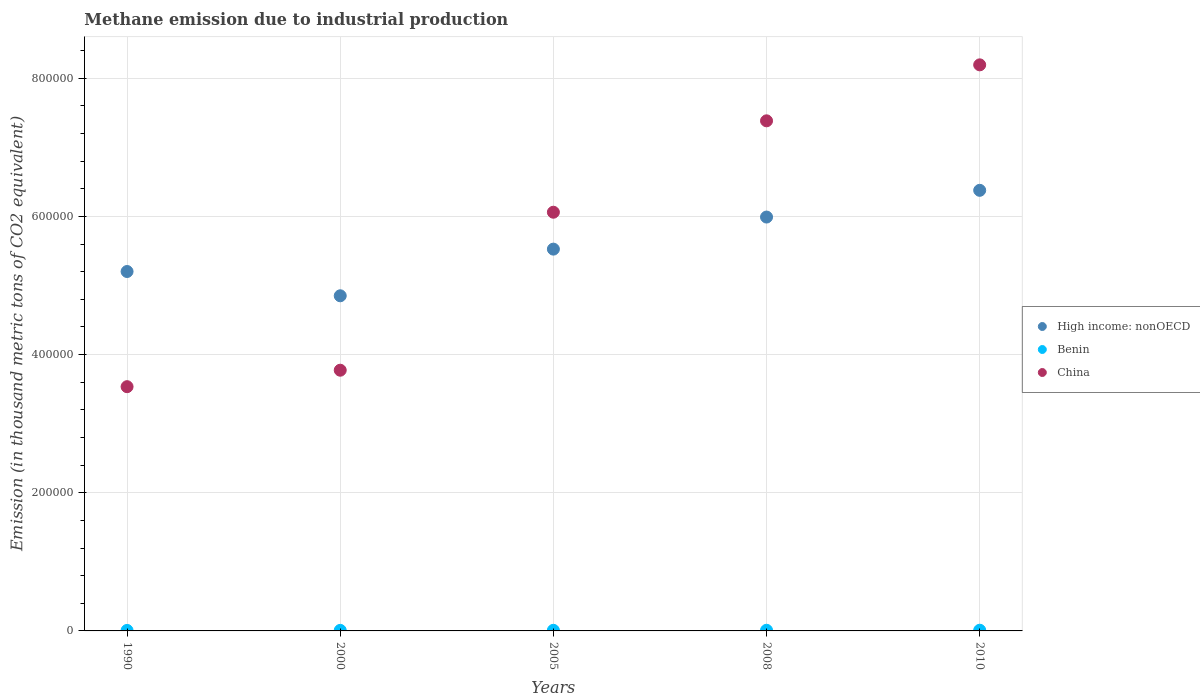What is the amount of methane emitted in High income: nonOECD in 2005?
Your answer should be compact. 5.53e+05. Across all years, what is the maximum amount of methane emitted in Benin?
Offer a terse response. 1014.3. Across all years, what is the minimum amount of methane emitted in Benin?
Keep it short and to the point. 711.4. In which year was the amount of methane emitted in High income: nonOECD minimum?
Ensure brevity in your answer.  2000. What is the total amount of methane emitted in China in the graph?
Offer a very short reply. 2.89e+06. What is the difference between the amount of methane emitted in High income: nonOECD in 1990 and that in 2010?
Keep it short and to the point. -1.18e+05. What is the difference between the amount of methane emitted in Benin in 2005 and the amount of methane emitted in High income: nonOECD in 2010?
Your answer should be compact. -6.37e+05. What is the average amount of methane emitted in China per year?
Provide a succinct answer. 5.79e+05. In the year 2000, what is the difference between the amount of methane emitted in High income: nonOECD and amount of methane emitted in Benin?
Offer a terse response. 4.84e+05. In how many years, is the amount of methane emitted in China greater than 40000 thousand metric tons?
Provide a short and direct response. 5. What is the ratio of the amount of methane emitted in Benin in 1990 to that in 2008?
Give a very brief answer. 0.75. What is the difference between the highest and the second highest amount of methane emitted in China?
Provide a succinct answer. 8.10e+04. What is the difference between the highest and the lowest amount of methane emitted in China?
Ensure brevity in your answer.  4.66e+05. Does the amount of methane emitted in Benin monotonically increase over the years?
Provide a succinct answer. Yes. Is the amount of methane emitted in China strictly less than the amount of methane emitted in Benin over the years?
Your answer should be compact. No. What is the difference between two consecutive major ticks on the Y-axis?
Provide a short and direct response. 2.00e+05. How many legend labels are there?
Make the answer very short. 3. What is the title of the graph?
Make the answer very short. Methane emission due to industrial production. Does "Small states" appear as one of the legend labels in the graph?
Make the answer very short. No. What is the label or title of the Y-axis?
Your response must be concise. Emission (in thousand metric tons of CO2 equivalent). What is the Emission (in thousand metric tons of CO2 equivalent) of High income: nonOECD in 1990?
Ensure brevity in your answer.  5.20e+05. What is the Emission (in thousand metric tons of CO2 equivalent) of Benin in 1990?
Make the answer very short. 711.4. What is the Emission (in thousand metric tons of CO2 equivalent) in China in 1990?
Ensure brevity in your answer.  3.54e+05. What is the Emission (in thousand metric tons of CO2 equivalent) in High income: nonOECD in 2000?
Provide a short and direct response. 4.85e+05. What is the Emission (in thousand metric tons of CO2 equivalent) in Benin in 2000?
Offer a terse response. 817.2. What is the Emission (in thousand metric tons of CO2 equivalent) of China in 2000?
Provide a short and direct response. 3.77e+05. What is the Emission (in thousand metric tons of CO2 equivalent) in High income: nonOECD in 2005?
Give a very brief answer. 5.53e+05. What is the Emission (in thousand metric tons of CO2 equivalent) of Benin in 2005?
Your answer should be very brief. 898.1. What is the Emission (in thousand metric tons of CO2 equivalent) of China in 2005?
Your response must be concise. 6.06e+05. What is the Emission (in thousand metric tons of CO2 equivalent) of High income: nonOECD in 2008?
Offer a very short reply. 5.99e+05. What is the Emission (in thousand metric tons of CO2 equivalent) in Benin in 2008?
Offer a very short reply. 950.4. What is the Emission (in thousand metric tons of CO2 equivalent) of China in 2008?
Give a very brief answer. 7.38e+05. What is the Emission (in thousand metric tons of CO2 equivalent) in High income: nonOECD in 2010?
Offer a very short reply. 6.38e+05. What is the Emission (in thousand metric tons of CO2 equivalent) of Benin in 2010?
Offer a terse response. 1014.3. What is the Emission (in thousand metric tons of CO2 equivalent) in China in 2010?
Your answer should be very brief. 8.19e+05. Across all years, what is the maximum Emission (in thousand metric tons of CO2 equivalent) of High income: nonOECD?
Make the answer very short. 6.38e+05. Across all years, what is the maximum Emission (in thousand metric tons of CO2 equivalent) in Benin?
Offer a terse response. 1014.3. Across all years, what is the maximum Emission (in thousand metric tons of CO2 equivalent) in China?
Offer a very short reply. 8.19e+05. Across all years, what is the minimum Emission (in thousand metric tons of CO2 equivalent) of High income: nonOECD?
Provide a short and direct response. 4.85e+05. Across all years, what is the minimum Emission (in thousand metric tons of CO2 equivalent) of Benin?
Keep it short and to the point. 711.4. Across all years, what is the minimum Emission (in thousand metric tons of CO2 equivalent) of China?
Your answer should be compact. 3.54e+05. What is the total Emission (in thousand metric tons of CO2 equivalent) in High income: nonOECD in the graph?
Ensure brevity in your answer.  2.79e+06. What is the total Emission (in thousand metric tons of CO2 equivalent) in Benin in the graph?
Ensure brevity in your answer.  4391.4. What is the total Emission (in thousand metric tons of CO2 equivalent) in China in the graph?
Your response must be concise. 2.89e+06. What is the difference between the Emission (in thousand metric tons of CO2 equivalent) of High income: nonOECD in 1990 and that in 2000?
Your answer should be compact. 3.51e+04. What is the difference between the Emission (in thousand metric tons of CO2 equivalent) of Benin in 1990 and that in 2000?
Your response must be concise. -105.8. What is the difference between the Emission (in thousand metric tons of CO2 equivalent) in China in 1990 and that in 2000?
Your response must be concise. -2.38e+04. What is the difference between the Emission (in thousand metric tons of CO2 equivalent) of High income: nonOECD in 1990 and that in 2005?
Your answer should be very brief. -3.24e+04. What is the difference between the Emission (in thousand metric tons of CO2 equivalent) in Benin in 1990 and that in 2005?
Offer a very short reply. -186.7. What is the difference between the Emission (in thousand metric tons of CO2 equivalent) of China in 1990 and that in 2005?
Ensure brevity in your answer.  -2.53e+05. What is the difference between the Emission (in thousand metric tons of CO2 equivalent) of High income: nonOECD in 1990 and that in 2008?
Ensure brevity in your answer.  -7.88e+04. What is the difference between the Emission (in thousand metric tons of CO2 equivalent) of Benin in 1990 and that in 2008?
Offer a terse response. -239. What is the difference between the Emission (in thousand metric tons of CO2 equivalent) of China in 1990 and that in 2008?
Provide a short and direct response. -3.85e+05. What is the difference between the Emission (in thousand metric tons of CO2 equivalent) in High income: nonOECD in 1990 and that in 2010?
Ensure brevity in your answer.  -1.18e+05. What is the difference between the Emission (in thousand metric tons of CO2 equivalent) of Benin in 1990 and that in 2010?
Ensure brevity in your answer.  -302.9. What is the difference between the Emission (in thousand metric tons of CO2 equivalent) in China in 1990 and that in 2010?
Offer a terse response. -4.66e+05. What is the difference between the Emission (in thousand metric tons of CO2 equivalent) in High income: nonOECD in 2000 and that in 2005?
Make the answer very short. -6.75e+04. What is the difference between the Emission (in thousand metric tons of CO2 equivalent) in Benin in 2000 and that in 2005?
Your response must be concise. -80.9. What is the difference between the Emission (in thousand metric tons of CO2 equivalent) in China in 2000 and that in 2005?
Provide a succinct answer. -2.29e+05. What is the difference between the Emission (in thousand metric tons of CO2 equivalent) in High income: nonOECD in 2000 and that in 2008?
Your answer should be compact. -1.14e+05. What is the difference between the Emission (in thousand metric tons of CO2 equivalent) of Benin in 2000 and that in 2008?
Provide a short and direct response. -133.2. What is the difference between the Emission (in thousand metric tons of CO2 equivalent) in China in 2000 and that in 2008?
Ensure brevity in your answer.  -3.61e+05. What is the difference between the Emission (in thousand metric tons of CO2 equivalent) in High income: nonOECD in 2000 and that in 2010?
Provide a succinct answer. -1.53e+05. What is the difference between the Emission (in thousand metric tons of CO2 equivalent) in Benin in 2000 and that in 2010?
Your answer should be very brief. -197.1. What is the difference between the Emission (in thousand metric tons of CO2 equivalent) of China in 2000 and that in 2010?
Make the answer very short. -4.42e+05. What is the difference between the Emission (in thousand metric tons of CO2 equivalent) of High income: nonOECD in 2005 and that in 2008?
Give a very brief answer. -4.64e+04. What is the difference between the Emission (in thousand metric tons of CO2 equivalent) in Benin in 2005 and that in 2008?
Give a very brief answer. -52.3. What is the difference between the Emission (in thousand metric tons of CO2 equivalent) of China in 2005 and that in 2008?
Make the answer very short. -1.32e+05. What is the difference between the Emission (in thousand metric tons of CO2 equivalent) in High income: nonOECD in 2005 and that in 2010?
Provide a short and direct response. -8.51e+04. What is the difference between the Emission (in thousand metric tons of CO2 equivalent) in Benin in 2005 and that in 2010?
Your response must be concise. -116.2. What is the difference between the Emission (in thousand metric tons of CO2 equivalent) of China in 2005 and that in 2010?
Provide a short and direct response. -2.13e+05. What is the difference between the Emission (in thousand metric tons of CO2 equivalent) in High income: nonOECD in 2008 and that in 2010?
Provide a short and direct response. -3.87e+04. What is the difference between the Emission (in thousand metric tons of CO2 equivalent) in Benin in 2008 and that in 2010?
Make the answer very short. -63.9. What is the difference between the Emission (in thousand metric tons of CO2 equivalent) in China in 2008 and that in 2010?
Your response must be concise. -8.10e+04. What is the difference between the Emission (in thousand metric tons of CO2 equivalent) in High income: nonOECD in 1990 and the Emission (in thousand metric tons of CO2 equivalent) in Benin in 2000?
Offer a very short reply. 5.19e+05. What is the difference between the Emission (in thousand metric tons of CO2 equivalent) in High income: nonOECD in 1990 and the Emission (in thousand metric tons of CO2 equivalent) in China in 2000?
Offer a terse response. 1.43e+05. What is the difference between the Emission (in thousand metric tons of CO2 equivalent) of Benin in 1990 and the Emission (in thousand metric tons of CO2 equivalent) of China in 2000?
Make the answer very short. -3.77e+05. What is the difference between the Emission (in thousand metric tons of CO2 equivalent) in High income: nonOECD in 1990 and the Emission (in thousand metric tons of CO2 equivalent) in Benin in 2005?
Your response must be concise. 5.19e+05. What is the difference between the Emission (in thousand metric tons of CO2 equivalent) in High income: nonOECD in 1990 and the Emission (in thousand metric tons of CO2 equivalent) in China in 2005?
Your answer should be compact. -8.58e+04. What is the difference between the Emission (in thousand metric tons of CO2 equivalent) of Benin in 1990 and the Emission (in thousand metric tons of CO2 equivalent) of China in 2005?
Ensure brevity in your answer.  -6.05e+05. What is the difference between the Emission (in thousand metric tons of CO2 equivalent) of High income: nonOECD in 1990 and the Emission (in thousand metric tons of CO2 equivalent) of Benin in 2008?
Provide a short and direct response. 5.19e+05. What is the difference between the Emission (in thousand metric tons of CO2 equivalent) in High income: nonOECD in 1990 and the Emission (in thousand metric tons of CO2 equivalent) in China in 2008?
Offer a terse response. -2.18e+05. What is the difference between the Emission (in thousand metric tons of CO2 equivalent) of Benin in 1990 and the Emission (in thousand metric tons of CO2 equivalent) of China in 2008?
Ensure brevity in your answer.  -7.38e+05. What is the difference between the Emission (in thousand metric tons of CO2 equivalent) of High income: nonOECD in 1990 and the Emission (in thousand metric tons of CO2 equivalent) of Benin in 2010?
Offer a very short reply. 5.19e+05. What is the difference between the Emission (in thousand metric tons of CO2 equivalent) in High income: nonOECD in 1990 and the Emission (in thousand metric tons of CO2 equivalent) in China in 2010?
Make the answer very short. -2.99e+05. What is the difference between the Emission (in thousand metric tons of CO2 equivalent) of Benin in 1990 and the Emission (in thousand metric tons of CO2 equivalent) of China in 2010?
Your answer should be very brief. -8.19e+05. What is the difference between the Emission (in thousand metric tons of CO2 equivalent) in High income: nonOECD in 2000 and the Emission (in thousand metric tons of CO2 equivalent) in Benin in 2005?
Your answer should be compact. 4.84e+05. What is the difference between the Emission (in thousand metric tons of CO2 equivalent) in High income: nonOECD in 2000 and the Emission (in thousand metric tons of CO2 equivalent) in China in 2005?
Your answer should be compact. -1.21e+05. What is the difference between the Emission (in thousand metric tons of CO2 equivalent) in Benin in 2000 and the Emission (in thousand metric tons of CO2 equivalent) in China in 2005?
Keep it short and to the point. -6.05e+05. What is the difference between the Emission (in thousand metric tons of CO2 equivalent) of High income: nonOECD in 2000 and the Emission (in thousand metric tons of CO2 equivalent) of Benin in 2008?
Your answer should be very brief. 4.84e+05. What is the difference between the Emission (in thousand metric tons of CO2 equivalent) in High income: nonOECD in 2000 and the Emission (in thousand metric tons of CO2 equivalent) in China in 2008?
Provide a short and direct response. -2.53e+05. What is the difference between the Emission (in thousand metric tons of CO2 equivalent) in Benin in 2000 and the Emission (in thousand metric tons of CO2 equivalent) in China in 2008?
Provide a succinct answer. -7.37e+05. What is the difference between the Emission (in thousand metric tons of CO2 equivalent) of High income: nonOECD in 2000 and the Emission (in thousand metric tons of CO2 equivalent) of Benin in 2010?
Your answer should be very brief. 4.84e+05. What is the difference between the Emission (in thousand metric tons of CO2 equivalent) in High income: nonOECD in 2000 and the Emission (in thousand metric tons of CO2 equivalent) in China in 2010?
Provide a succinct answer. -3.34e+05. What is the difference between the Emission (in thousand metric tons of CO2 equivalent) of Benin in 2000 and the Emission (in thousand metric tons of CO2 equivalent) of China in 2010?
Give a very brief answer. -8.18e+05. What is the difference between the Emission (in thousand metric tons of CO2 equivalent) in High income: nonOECD in 2005 and the Emission (in thousand metric tons of CO2 equivalent) in Benin in 2008?
Give a very brief answer. 5.52e+05. What is the difference between the Emission (in thousand metric tons of CO2 equivalent) of High income: nonOECD in 2005 and the Emission (in thousand metric tons of CO2 equivalent) of China in 2008?
Keep it short and to the point. -1.86e+05. What is the difference between the Emission (in thousand metric tons of CO2 equivalent) in Benin in 2005 and the Emission (in thousand metric tons of CO2 equivalent) in China in 2008?
Your response must be concise. -7.37e+05. What is the difference between the Emission (in thousand metric tons of CO2 equivalent) of High income: nonOECD in 2005 and the Emission (in thousand metric tons of CO2 equivalent) of Benin in 2010?
Give a very brief answer. 5.52e+05. What is the difference between the Emission (in thousand metric tons of CO2 equivalent) of High income: nonOECD in 2005 and the Emission (in thousand metric tons of CO2 equivalent) of China in 2010?
Give a very brief answer. -2.67e+05. What is the difference between the Emission (in thousand metric tons of CO2 equivalent) of Benin in 2005 and the Emission (in thousand metric tons of CO2 equivalent) of China in 2010?
Keep it short and to the point. -8.18e+05. What is the difference between the Emission (in thousand metric tons of CO2 equivalent) in High income: nonOECD in 2008 and the Emission (in thousand metric tons of CO2 equivalent) in Benin in 2010?
Your response must be concise. 5.98e+05. What is the difference between the Emission (in thousand metric tons of CO2 equivalent) in High income: nonOECD in 2008 and the Emission (in thousand metric tons of CO2 equivalent) in China in 2010?
Your response must be concise. -2.20e+05. What is the difference between the Emission (in thousand metric tons of CO2 equivalent) in Benin in 2008 and the Emission (in thousand metric tons of CO2 equivalent) in China in 2010?
Provide a succinct answer. -8.18e+05. What is the average Emission (in thousand metric tons of CO2 equivalent) in High income: nonOECD per year?
Offer a terse response. 5.59e+05. What is the average Emission (in thousand metric tons of CO2 equivalent) of Benin per year?
Provide a succinct answer. 878.28. What is the average Emission (in thousand metric tons of CO2 equivalent) in China per year?
Make the answer very short. 5.79e+05. In the year 1990, what is the difference between the Emission (in thousand metric tons of CO2 equivalent) in High income: nonOECD and Emission (in thousand metric tons of CO2 equivalent) in Benin?
Provide a succinct answer. 5.19e+05. In the year 1990, what is the difference between the Emission (in thousand metric tons of CO2 equivalent) of High income: nonOECD and Emission (in thousand metric tons of CO2 equivalent) of China?
Your answer should be very brief. 1.67e+05. In the year 1990, what is the difference between the Emission (in thousand metric tons of CO2 equivalent) of Benin and Emission (in thousand metric tons of CO2 equivalent) of China?
Offer a very short reply. -3.53e+05. In the year 2000, what is the difference between the Emission (in thousand metric tons of CO2 equivalent) in High income: nonOECD and Emission (in thousand metric tons of CO2 equivalent) in Benin?
Make the answer very short. 4.84e+05. In the year 2000, what is the difference between the Emission (in thousand metric tons of CO2 equivalent) of High income: nonOECD and Emission (in thousand metric tons of CO2 equivalent) of China?
Provide a succinct answer. 1.08e+05. In the year 2000, what is the difference between the Emission (in thousand metric tons of CO2 equivalent) in Benin and Emission (in thousand metric tons of CO2 equivalent) in China?
Make the answer very short. -3.77e+05. In the year 2005, what is the difference between the Emission (in thousand metric tons of CO2 equivalent) in High income: nonOECD and Emission (in thousand metric tons of CO2 equivalent) in Benin?
Give a very brief answer. 5.52e+05. In the year 2005, what is the difference between the Emission (in thousand metric tons of CO2 equivalent) in High income: nonOECD and Emission (in thousand metric tons of CO2 equivalent) in China?
Provide a succinct answer. -5.34e+04. In the year 2005, what is the difference between the Emission (in thousand metric tons of CO2 equivalent) of Benin and Emission (in thousand metric tons of CO2 equivalent) of China?
Your answer should be very brief. -6.05e+05. In the year 2008, what is the difference between the Emission (in thousand metric tons of CO2 equivalent) in High income: nonOECD and Emission (in thousand metric tons of CO2 equivalent) in Benin?
Make the answer very short. 5.98e+05. In the year 2008, what is the difference between the Emission (in thousand metric tons of CO2 equivalent) in High income: nonOECD and Emission (in thousand metric tons of CO2 equivalent) in China?
Offer a terse response. -1.39e+05. In the year 2008, what is the difference between the Emission (in thousand metric tons of CO2 equivalent) of Benin and Emission (in thousand metric tons of CO2 equivalent) of China?
Your answer should be compact. -7.37e+05. In the year 2010, what is the difference between the Emission (in thousand metric tons of CO2 equivalent) in High income: nonOECD and Emission (in thousand metric tons of CO2 equivalent) in Benin?
Keep it short and to the point. 6.37e+05. In the year 2010, what is the difference between the Emission (in thousand metric tons of CO2 equivalent) in High income: nonOECD and Emission (in thousand metric tons of CO2 equivalent) in China?
Make the answer very short. -1.82e+05. In the year 2010, what is the difference between the Emission (in thousand metric tons of CO2 equivalent) of Benin and Emission (in thousand metric tons of CO2 equivalent) of China?
Your answer should be very brief. -8.18e+05. What is the ratio of the Emission (in thousand metric tons of CO2 equivalent) of High income: nonOECD in 1990 to that in 2000?
Your answer should be compact. 1.07. What is the ratio of the Emission (in thousand metric tons of CO2 equivalent) of Benin in 1990 to that in 2000?
Ensure brevity in your answer.  0.87. What is the ratio of the Emission (in thousand metric tons of CO2 equivalent) in China in 1990 to that in 2000?
Ensure brevity in your answer.  0.94. What is the ratio of the Emission (in thousand metric tons of CO2 equivalent) in High income: nonOECD in 1990 to that in 2005?
Provide a short and direct response. 0.94. What is the ratio of the Emission (in thousand metric tons of CO2 equivalent) in Benin in 1990 to that in 2005?
Provide a succinct answer. 0.79. What is the ratio of the Emission (in thousand metric tons of CO2 equivalent) in China in 1990 to that in 2005?
Offer a terse response. 0.58. What is the ratio of the Emission (in thousand metric tons of CO2 equivalent) in High income: nonOECD in 1990 to that in 2008?
Your answer should be very brief. 0.87. What is the ratio of the Emission (in thousand metric tons of CO2 equivalent) of Benin in 1990 to that in 2008?
Give a very brief answer. 0.75. What is the ratio of the Emission (in thousand metric tons of CO2 equivalent) in China in 1990 to that in 2008?
Provide a short and direct response. 0.48. What is the ratio of the Emission (in thousand metric tons of CO2 equivalent) of High income: nonOECD in 1990 to that in 2010?
Make the answer very short. 0.82. What is the ratio of the Emission (in thousand metric tons of CO2 equivalent) of Benin in 1990 to that in 2010?
Your answer should be very brief. 0.7. What is the ratio of the Emission (in thousand metric tons of CO2 equivalent) in China in 1990 to that in 2010?
Offer a terse response. 0.43. What is the ratio of the Emission (in thousand metric tons of CO2 equivalent) of High income: nonOECD in 2000 to that in 2005?
Ensure brevity in your answer.  0.88. What is the ratio of the Emission (in thousand metric tons of CO2 equivalent) of Benin in 2000 to that in 2005?
Provide a succinct answer. 0.91. What is the ratio of the Emission (in thousand metric tons of CO2 equivalent) in China in 2000 to that in 2005?
Provide a succinct answer. 0.62. What is the ratio of the Emission (in thousand metric tons of CO2 equivalent) in High income: nonOECD in 2000 to that in 2008?
Provide a short and direct response. 0.81. What is the ratio of the Emission (in thousand metric tons of CO2 equivalent) in Benin in 2000 to that in 2008?
Offer a very short reply. 0.86. What is the ratio of the Emission (in thousand metric tons of CO2 equivalent) of China in 2000 to that in 2008?
Your answer should be very brief. 0.51. What is the ratio of the Emission (in thousand metric tons of CO2 equivalent) in High income: nonOECD in 2000 to that in 2010?
Provide a succinct answer. 0.76. What is the ratio of the Emission (in thousand metric tons of CO2 equivalent) in Benin in 2000 to that in 2010?
Offer a terse response. 0.81. What is the ratio of the Emission (in thousand metric tons of CO2 equivalent) of China in 2000 to that in 2010?
Your answer should be very brief. 0.46. What is the ratio of the Emission (in thousand metric tons of CO2 equivalent) of High income: nonOECD in 2005 to that in 2008?
Offer a very short reply. 0.92. What is the ratio of the Emission (in thousand metric tons of CO2 equivalent) of Benin in 2005 to that in 2008?
Provide a short and direct response. 0.94. What is the ratio of the Emission (in thousand metric tons of CO2 equivalent) of China in 2005 to that in 2008?
Your answer should be compact. 0.82. What is the ratio of the Emission (in thousand metric tons of CO2 equivalent) in High income: nonOECD in 2005 to that in 2010?
Offer a terse response. 0.87. What is the ratio of the Emission (in thousand metric tons of CO2 equivalent) in Benin in 2005 to that in 2010?
Give a very brief answer. 0.89. What is the ratio of the Emission (in thousand metric tons of CO2 equivalent) of China in 2005 to that in 2010?
Give a very brief answer. 0.74. What is the ratio of the Emission (in thousand metric tons of CO2 equivalent) of High income: nonOECD in 2008 to that in 2010?
Your answer should be compact. 0.94. What is the ratio of the Emission (in thousand metric tons of CO2 equivalent) of Benin in 2008 to that in 2010?
Offer a very short reply. 0.94. What is the ratio of the Emission (in thousand metric tons of CO2 equivalent) of China in 2008 to that in 2010?
Provide a short and direct response. 0.9. What is the difference between the highest and the second highest Emission (in thousand metric tons of CO2 equivalent) of High income: nonOECD?
Ensure brevity in your answer.  3.87e+04. What is the difference between the highest and the second highest Emission (in thousand metric tons of CO2 equivalent) of Benin?
Provide a short and direct response. 63.9. What is the difference between the highest and the second highest Emission (in thousand metric tons of CO2 equivalent) of China?
Ensure brevity in your answer.  8.10e+04. What is the difference between the highest and the lowest Emission (in thousand metric tons of CO2 equivalent) of High income: nonOECD?
Your answer should be very brief. 1.53e+05. What is the difference between the highest and the lowest Emission (in thousand metric tons of CO2 equivalent) of Benin?
Provide a short and direct response. 302.9. What is the difference between the highest and the lowest Emission (in thousand metric tons of CO2 equivalent) of China?
Provide a succinct answer. 4.66e+05. 